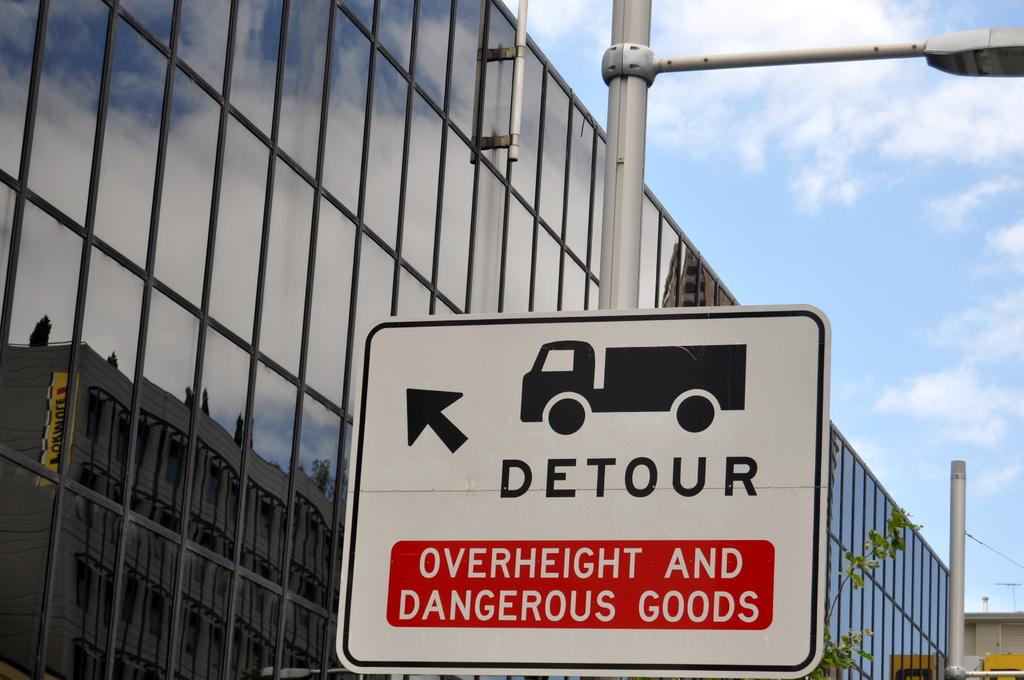What should overheight trucks do?
Offer a very short reply. Detour. What does the sign say that the detour is for?
Offer a terse response. Overheight and dangerous goods. 